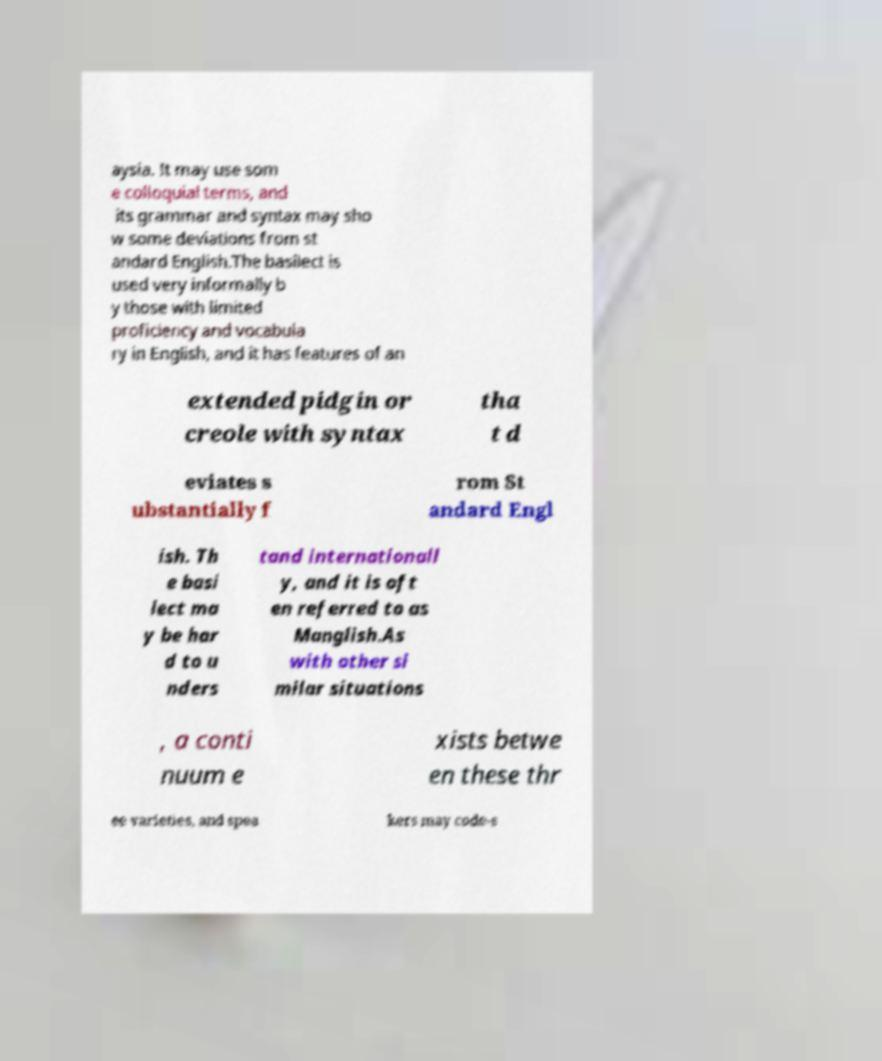What messages or text are displayed in this image? I need them in a readable, typed format. aysia. It may use som e colloquial terms, and its grammar and syntax may sho w some deviations from st andard English.The basilect is used very informally b y those with limited proficiency and vocabula ry in English, and it has features of an extended pidgin or creole with syntax tha t d eviates s ubstantially f rom St andard Engl ish. Th e basi lect ma y be har d to u nders tand internationall y, and it is oft en referred to as Manglish.As with other si milar situations , a conti nuum e xists betwe en these thr ee varieties, and spea kers may code-s 